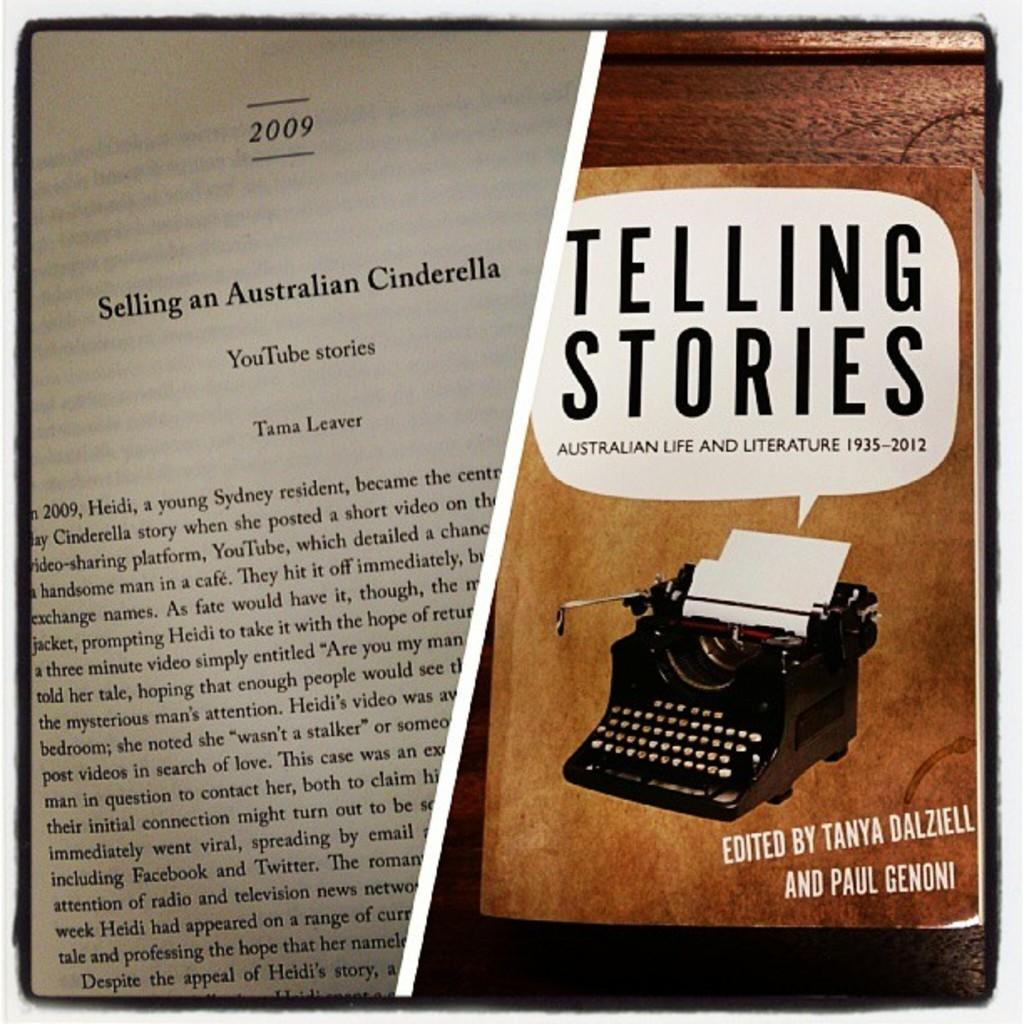<image>
Provide a brief description of the given image. A book called Telling Stories explores Australian Life and Literature from 1935 to 2012. 